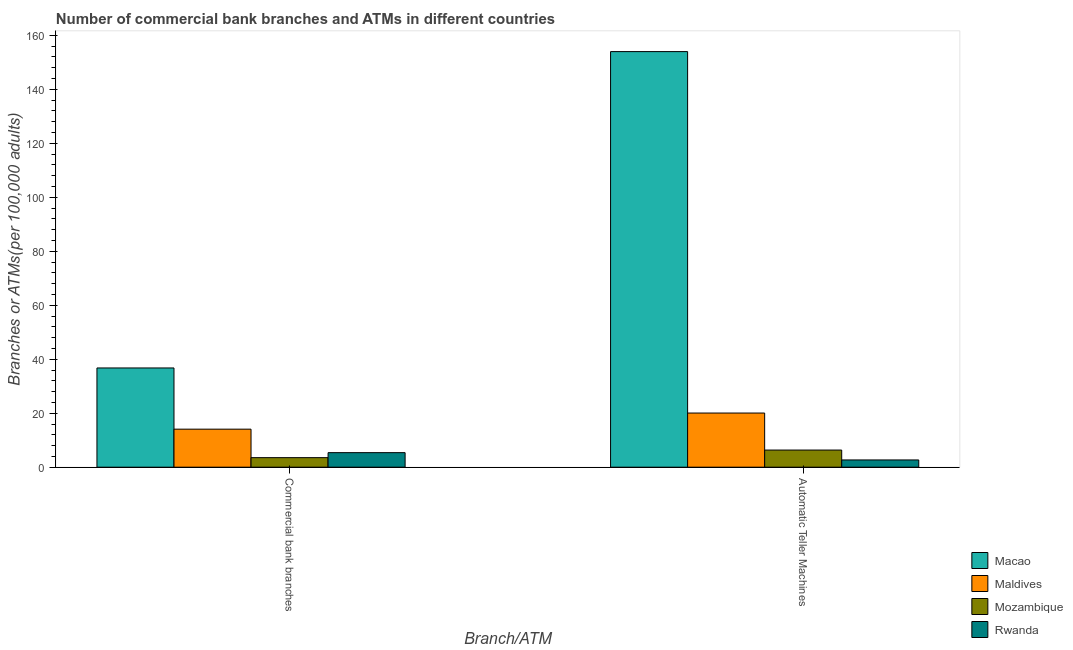Are the number of bars on each tick of the X-axis equal?
Keep it short and to the point. Yes. What is the label of the 1st group of bars from the left?
Give a very brief answer. Commercial bank branches. What is the number of commercal bank branches in Rwanda?
Ensure brevity in your answer.  5.39. Across all countries, what is the maximum number of atms?
Offer a very short reply. 153.98. Across all countries, what is the minimum number of atms?
Provide a succinct answer. 2.69. In which country was the number of atms maximum?
Your answer should be compact. Macao. In which country was the number of atms minimum?
Give a very brief answer. Rwanda. What is the total number of atms in the graph?
Your answer should be very brief. 183.08. What is the difference between the number of atms in Mozambique and that in Maldives?
Your answer should be very brief. -13.72. What is the difference between the number of atms in Maldives and the number of commercal bank branches in Macao?
Give a very brief answer. -16.7. What is the average number of commercal bank branches per country?
Provide a short and direct response. 14.95. What is the difference between the number of commercal bank branches and number of atms in Mozambique?
Your answer should be compact. -2.82. In how many countries, is the number of commercal bank branches greater than 116 ?
Give a very brief answer. 0. What is the ratio of the number of commercal bank branches in Maldives to that in Rwanda?
Provide a short and direct response. 2.61. Is the number of atms in Macao less than that in Maldives?
Your answer should be very brief. No. What does the 4th bar from the left in Commercial bank branches represents?
Your answer should be very brief. Rwanda. What does the 4th bar from the right in Automatic Teller Machines represents?
Provide a succinct answer. Macao. How many bars are there?
Keep it short and to the point. 8. How many countries are there in the graph?
Your answer should be compact. 4. Are the values on the major ticks of Y-axis written in scientific E-notation?
Your response must be concise. No. How are the legend labels stacked?
Your answer should be compact. Vertical. What is the title of the graph?
Make the answer very short. Number of commercial bank branches and ATMs in different countries. What is the label or title of the X-axis?
Keep it short and to the point. Branch/ATM. What is the label or title of the Y-axis?
Offer a very short reply. Branches or ATMs(per 100,0 adults). What is the Branches or ATMs(per 100,000 adults) of Macao in Commercial bank branches?
Your answer should be very brief. 36.77. What is the Branches or ATMs(per 100,000 adults) of Maldives in Commercial bank branches?
Make the answer very short. 14.09. What is the Branches or ATMs(per 100,000 adults) in Mozambique in Commercial bank branches?
Your answer should be very brief. 3.54. What is the Branches or ATMs(per 100,000 adults) of Rwanda in Commercial bank branches?
Ensure brevity in your answer.  5.39. What is the Branches or ATMs(per 100,000 adults) in Macao in Automatic Teller Machines?
Provide a succinct answer. 153.98. What is the Branches or ATMs(per 100,000 adults) of Maldives in Automatic Teller Machines?
Provide a succinct answer. 20.07. What is the Branches or ATMs(per 100,000 adults) in Mozambique in Automatic Teller Machines?
Make the answer very short. 6.35. What is the Branches or ATMs(per 100,000 adults) of Rwanda in Automatic Teller Machines?
Give a very brief answer. 2.69. Across all Branch/ATM, what is the maximum Branches or ATMs(per 100,000 adults) of Macao?
Keep it short and to the point. 153.98. Across all Branch/ATM, what is the maximum Branches or ATMs(per 100,000 adults) of Maldives?
Your answer should be very brief. 20.07. Across all Branch/ATM, what is the maximum Branches or ATMs(per 100,000 adults) in Mozambique?
Ensure brevity in your answer.  6.35. Across all Branch/ATM, what is the maximum Branches or ATMs(per 100,000 adults) in Rwanda?
Provide a short and direct response. 5.39. Across all Branch/ATM, what is the minimum Branches or ATMs(per 100,000 adults) in Macao?
Your response must be concise. 36.77. Across all Branch/ATM, what is the minimum Branches or ATMs(per 100,000 adults) of Maldives?
Give a very brief answer. 14.09. Across all Branch/ATM, what is the minimum Branches or ATMs(per 100,000 adults) of Mozambique?
Keep it short and to the point. 3.54. Across all Branch/ATM, what is the minimum Branches or ATMs(per 100,000 adults) of Rwanda?
Keep it short and to the point. 2.69. What is the total Branches or ATMs(per 100,000 adults) in Macao in the graph?
Make the answer very short. 190.75. What is the total Branches or ATMs(per 100,000 adults) of Maldives in the graph?
Ensure brevity in your answer.  34.16. What is the total Branches or ATMs(per 100,000 adults) of Mozambique in the graph?
Give a very brief answer. 9.89. What is the total Branches or ATMs(per 100,000 adults) in Rwanda in the graph?
Offer a terse response. 8.08. What is the difference between the Branches or ATMs(per 100,000 adults) of Macao in Commercial bank branches and that in Automatic Teller Machines?
Give a very brief answer. -117.21. What is the difference between the Branches or ATMs(per 100,000 adults) in Maldives in Commercial bank branches and that in Automatic Teller Machines?
Provide a short and direct response. -5.98. What is the difference between the Branches or ATMs(per 100,000 adults) in Mozambique in Commercial bank branches and that in Automatic Teller Machines?
Provide a short and direct response. -2.82. What is the difference between the Branches or ATMs(per 100,000 adults) in Rwanda in Commercial bank branches and that in Automatic Teller Machines?
Provide a succinct answer. 2.7. What is the difference between the Branches or ATMs(per 100,000 adults) of Macao in Commercial bank branches and the Branches or ATMs(per 100,000 adults) of Maldives in Automatic Teller Machines?
Your answer should be very brief. 16.7. What is the difference between the Branches or ATMs(per 100,000 adults) in Macao in Commercial bank branches and the Branches or ATMs(per 100,000 adults) in Mozambique in Automatic Teller Machines?
Provide a short and direct response. 30.42. What is the difference between the Branches or ATMs(per 100,000 adults) of Macao in Commercial bank branches and the Branches or ATMs(per 100,000 adults) of Rwanda in Automatic Teller Machines?
Offer a terse response. 34.08. What is the difference between the Branches or ATMs(per 100,000 adults) in Maldives in Commercial bank branches and the Branches or ATMs(per 100,000 adults) in Mozambique in Automatic Teller Machines?
Offer a terse response. 7.74. What is the difference between the Branches or ATMs(per 100,000 adults) of Maldives in Commercial bank branches and the Branches or ATMs(per 100,000 adults) of Rwanda in Automatic Teller Machines?
Your response must be concise. 11.4. What is the difference between the Branches or ATMs(per 100,000 adults) in Mozambique in Commercial bank branches and the Branches or ATMs(per 100,000 adults) in Rwanda in Automatic Teller Machines?
Your answer should be compact. 0.85. What is the average Branches or ATMs(per 100,000 adults) in Macao per Branch/ATM?
Keep it short and to the point. 95.37. What is the average Branches or ATMs(per 100,000 adults) in Maldives per Branch/ATM?
Provide a succinct answer. 17.08. What is the average Branches or ATMs(per 100,000 adults) in Mozambique per Branch/ATM?
Offer a terse response. 4.95. What is the average Branches or ATMs(per 100,000 adults) in Rwanda per Branch/ATM?
Keep it short and to the point. 4.04. What is the difference between the Branches or ATMs(per 100,000 adults) in Macao and Branches or ATMs(per 100,000 adults) in Maldives in Commercial bank branches?
Your answer should be very brief. 22.68. What is the difference between the Branches or ATMs(per 100,000 adults) in Macao and Branches or ATMs(per 100,000 adults) in Mozambique in Commercial bank branches?
Keep it short and to the point. 33.23. What is the difference between the Branches or ATMs(per 100,000 adults) of Macao and Branches or ATMs(per 100,000 adults) of Rwanda in Commercial bank branches?
Your answer should be very brief. 31.38. What is the difference between the Branches or ATMs(per 100,000 adults) in Maldives and Branches or ATMs(per 100,000 adults) in Mozambique in Commercial bank branches?
Your answer should be compact. 10.55. What is the difference between the Branches or ATMs(per 100,000 adults) of Maldives and Branches or ATMs(per 100,000 adults) of Rwanda in Commercial bank branches?
Your answer should be very brief. 8.7. What is the difference between the Branches or ATMs(per 100,000 adults) of Mozambique and Branches or ATMs(per 100,000 adults) of Rwanda in Commercial bank branches?
Your response must be concise. -1.85. What is the difference between the Branches or ATMs(per 100,000 adults) of Macao and Branches or ATMs(per 100,000 adults) of Maldives in Automatic Teller Machines?
Ensure brevity in your answer.  133.91. What is the difference between the Branches or ATMs(per 100,000 adults) of Macao and Branches or ATMs(per 100,000 adults) of Mozambique in Automatic Teller Machines?
Your answer should be very brief. 147.62. What is the difference between the Branches or ATMs(per 100,000 adults) in Macao and Branches or ATMs(per 100,000 adults) in Rwanda in Automatic Teller Machines?
Ensure brevity in your answer.  151.29. What is the difference between the Branches or ATMs(per 100,000 adults) of Maldives and Branches or ATMs(per 100,000 adults) of Mozambique in Automatic Teller Machines?
Your answer should be compact. 13.72. What is the difference between the Branches or ATMs(per 100,000 adults) of Maldives and Branches or ATMs(per 100,000 adults) of Rwanda in Automatic Teller Machines?
Make the answer very short. 17.38. What is the difference between the Branches or ATMs(per 100,000 adults) of Mozambique and Branches or ATMs(per 100,000 adults) of Rwanda in Automatic Teller Machines?
Your response must be concise. 3.67. What is the ratio of the Branches or ATMs(per 100,000 adults) of Macao in Commercial bank branches to that in Automatic Teller Machines?
Your answer should be very brief. 0.24. What is the ratio of the Branches or ATMs(per 100,000 adults) in Maldives in Commercial bank branches to that in Automatic Teller Machines?
Ensure brevity in your answer.  0.7. What is the ratio of the Branches or ATMs(per 100,000 adults) in Mozambique in Commercial bank branches to that in Automatic Teller Machines?
Provide a succinct answer. 0.56. What is the ratio of the Branches or ATMs(per 100,000 adults) in Rwanda in Commercial bank branches to that in Automatic Teller Machines?
Offer a terse response. 2.01. What is the difference between the highest and the second highest Branches or ATMs(per 100,000 adults) of Macao?
Give a very brief answer. 117.21. What is the difference between the highest and the second highest Branches or ATMs(per 100,000 adults) in Maldives?
Ensure brevity in your answer.  5.98. What is the difference between the highest and the second highest Branches or ATMs(per 100,000 adults) in Mozambique?
Your answer should be compact. 2.82. What is the difference between the highest and the second highest Branches or ATMs(per 100,000 adults) of Rwanda?
Your answer should be very brief. 2.7. What is the difference between the highest and the lowest Branches or ATMs(per 100,000 adults) in Macao?
Your answer should be compact. 117.21. What is the difference between the highest and the lowest Branches or ATMs(per 100,000 adults) in Maldives?
Provide a short and direct response. 5.98. What is the difference between the highest and the lowest Branches or ATMs(per 100,000 adults) in Mozambique?
Give a very brief answer. 2.82. What is the difference between the highest and the lowest Branches or ATMs(per 100,000 adults) of Rwanda?
Your answer should be very brief. 2.7. 